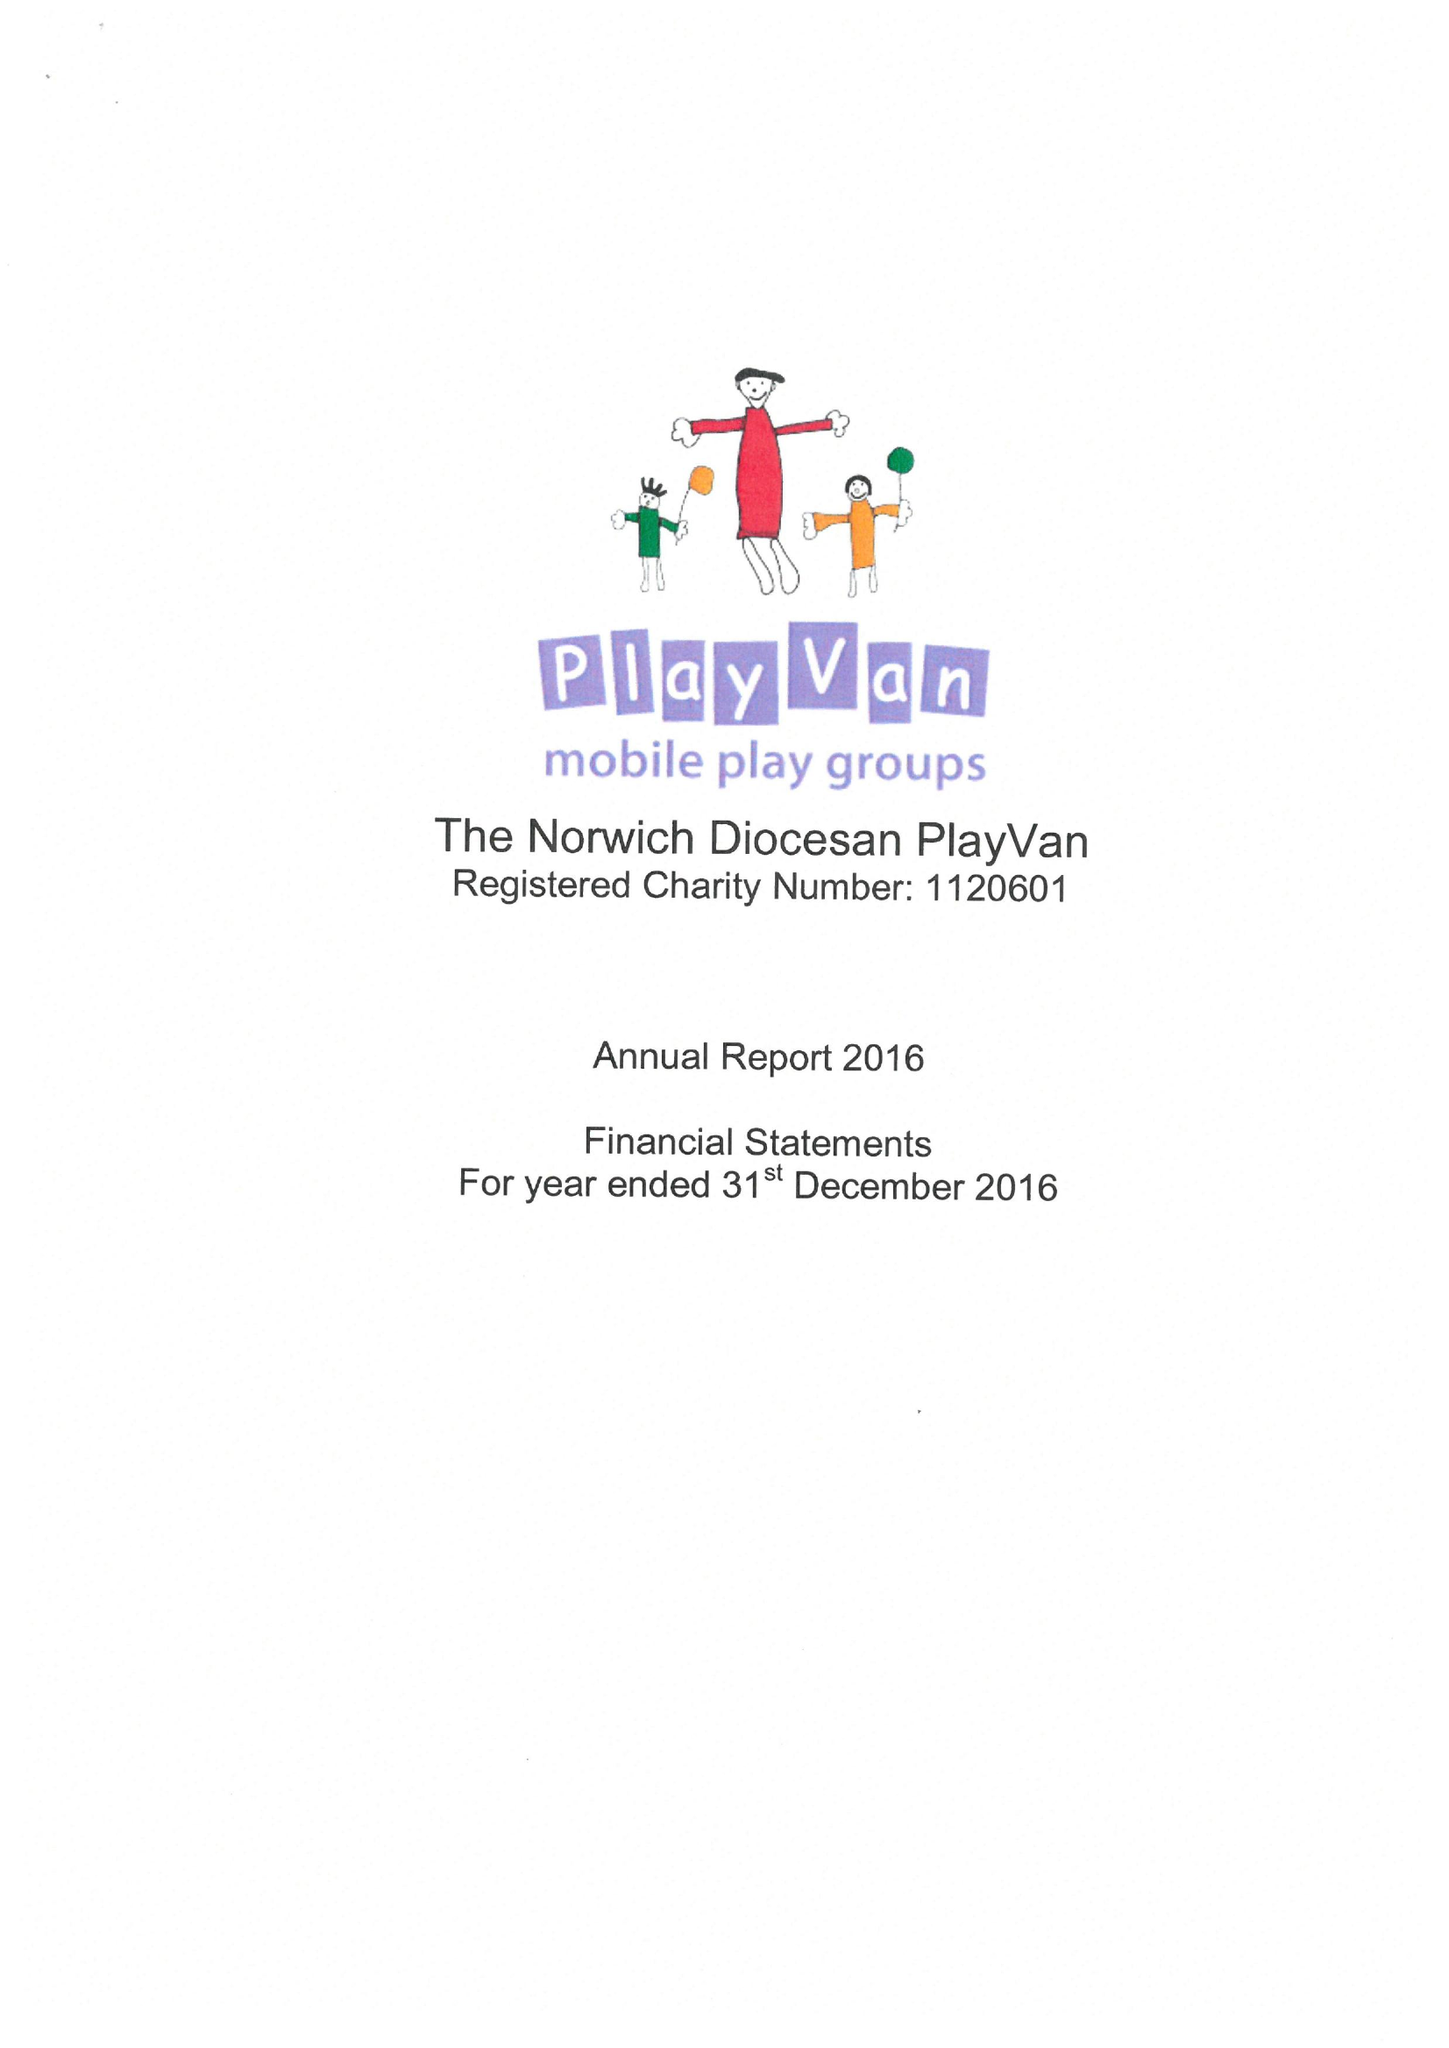What is the value for the report_date?
Answer the question using a single word or phrase. 2016-12-31 